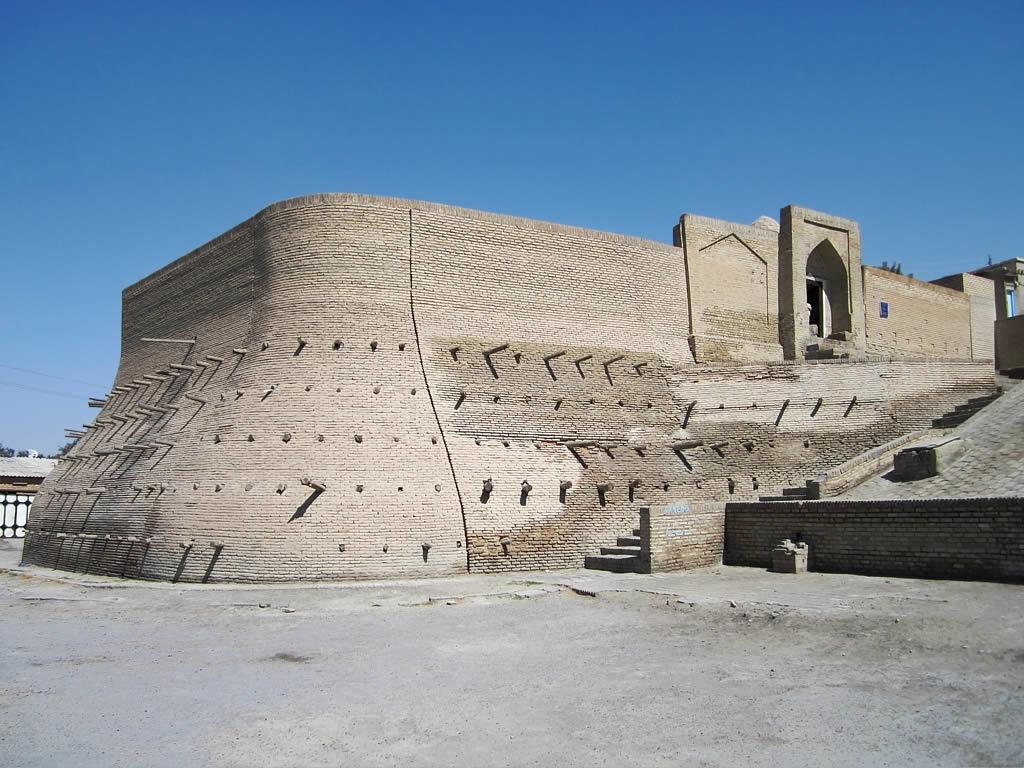In one or two sentences, can you explain what this image depicts? In this picture we can see a fort, stairs and poles. On the left side of the picture we can see a shed. At the bottom portion of the picture we can see the pathway. In the background we can see the sky and trees. 